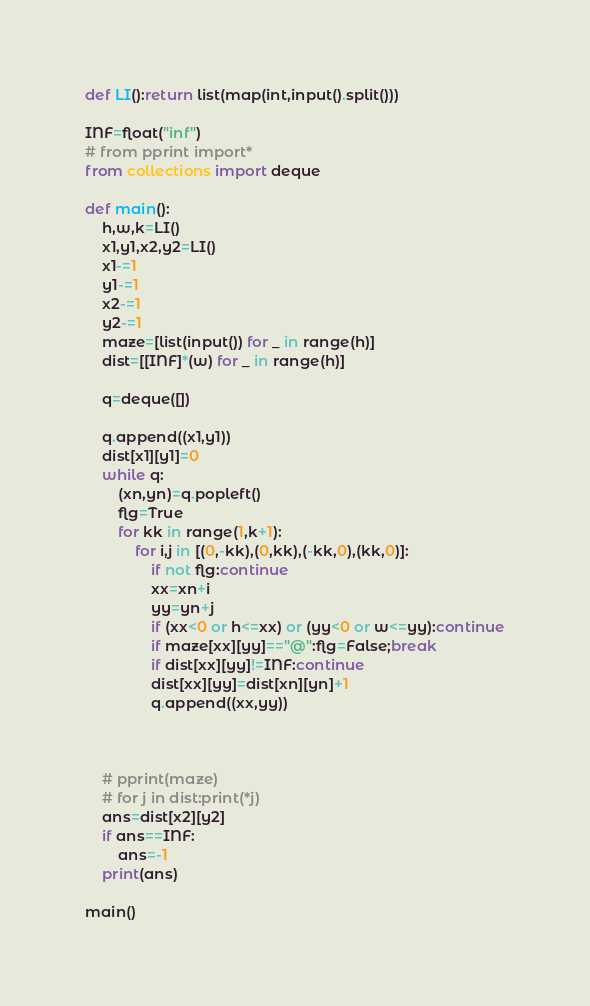<code> <loc_0><loc_0><loc_500><loc_500><_Cython_>def LI():return list(map(int,input().split()))

INF=float("inf")
# from pprint import*
from collections import deque

def main():
    h,w,k=LI()
    x1,y1,x2,y2=LI()
    x1-=1
    y1-=1
    x2-=1
    y2-=1
    maze=[list(input()) for _ in range(h)]
    dist=[[INF]*(w) for _ in range(h)]
    
    q=deque([])
    
    q.append((x1,y1))
    dist[x1][y1]=0
    while q:
        (xn,yn)=q.popleft()
        flg=True
        for kk in range(1,k+1):
            for i,j in [(0,-kk),(0,kk),(-kk,0),(kk,0)]:
                if not flg:continue
                xx=xn+i
                yy=yn+j
                if (xx<0 or h<=xx) or (yy<0 or w<=yy):continue
                if maze[xx][yy]=="@":flg=False;break
                if dist[xx][yy]!=INF:continue
                dist[xx][yy]=dist[xn][yn]+1
                q.append((xx,yy))

        
        
    # pprint(maze)
    # for j in dist:print(*j)
    ans=dist[x2][y2]
    if ans==INF:
        ans=-1
    print(ans)  
    
main()
</code> 